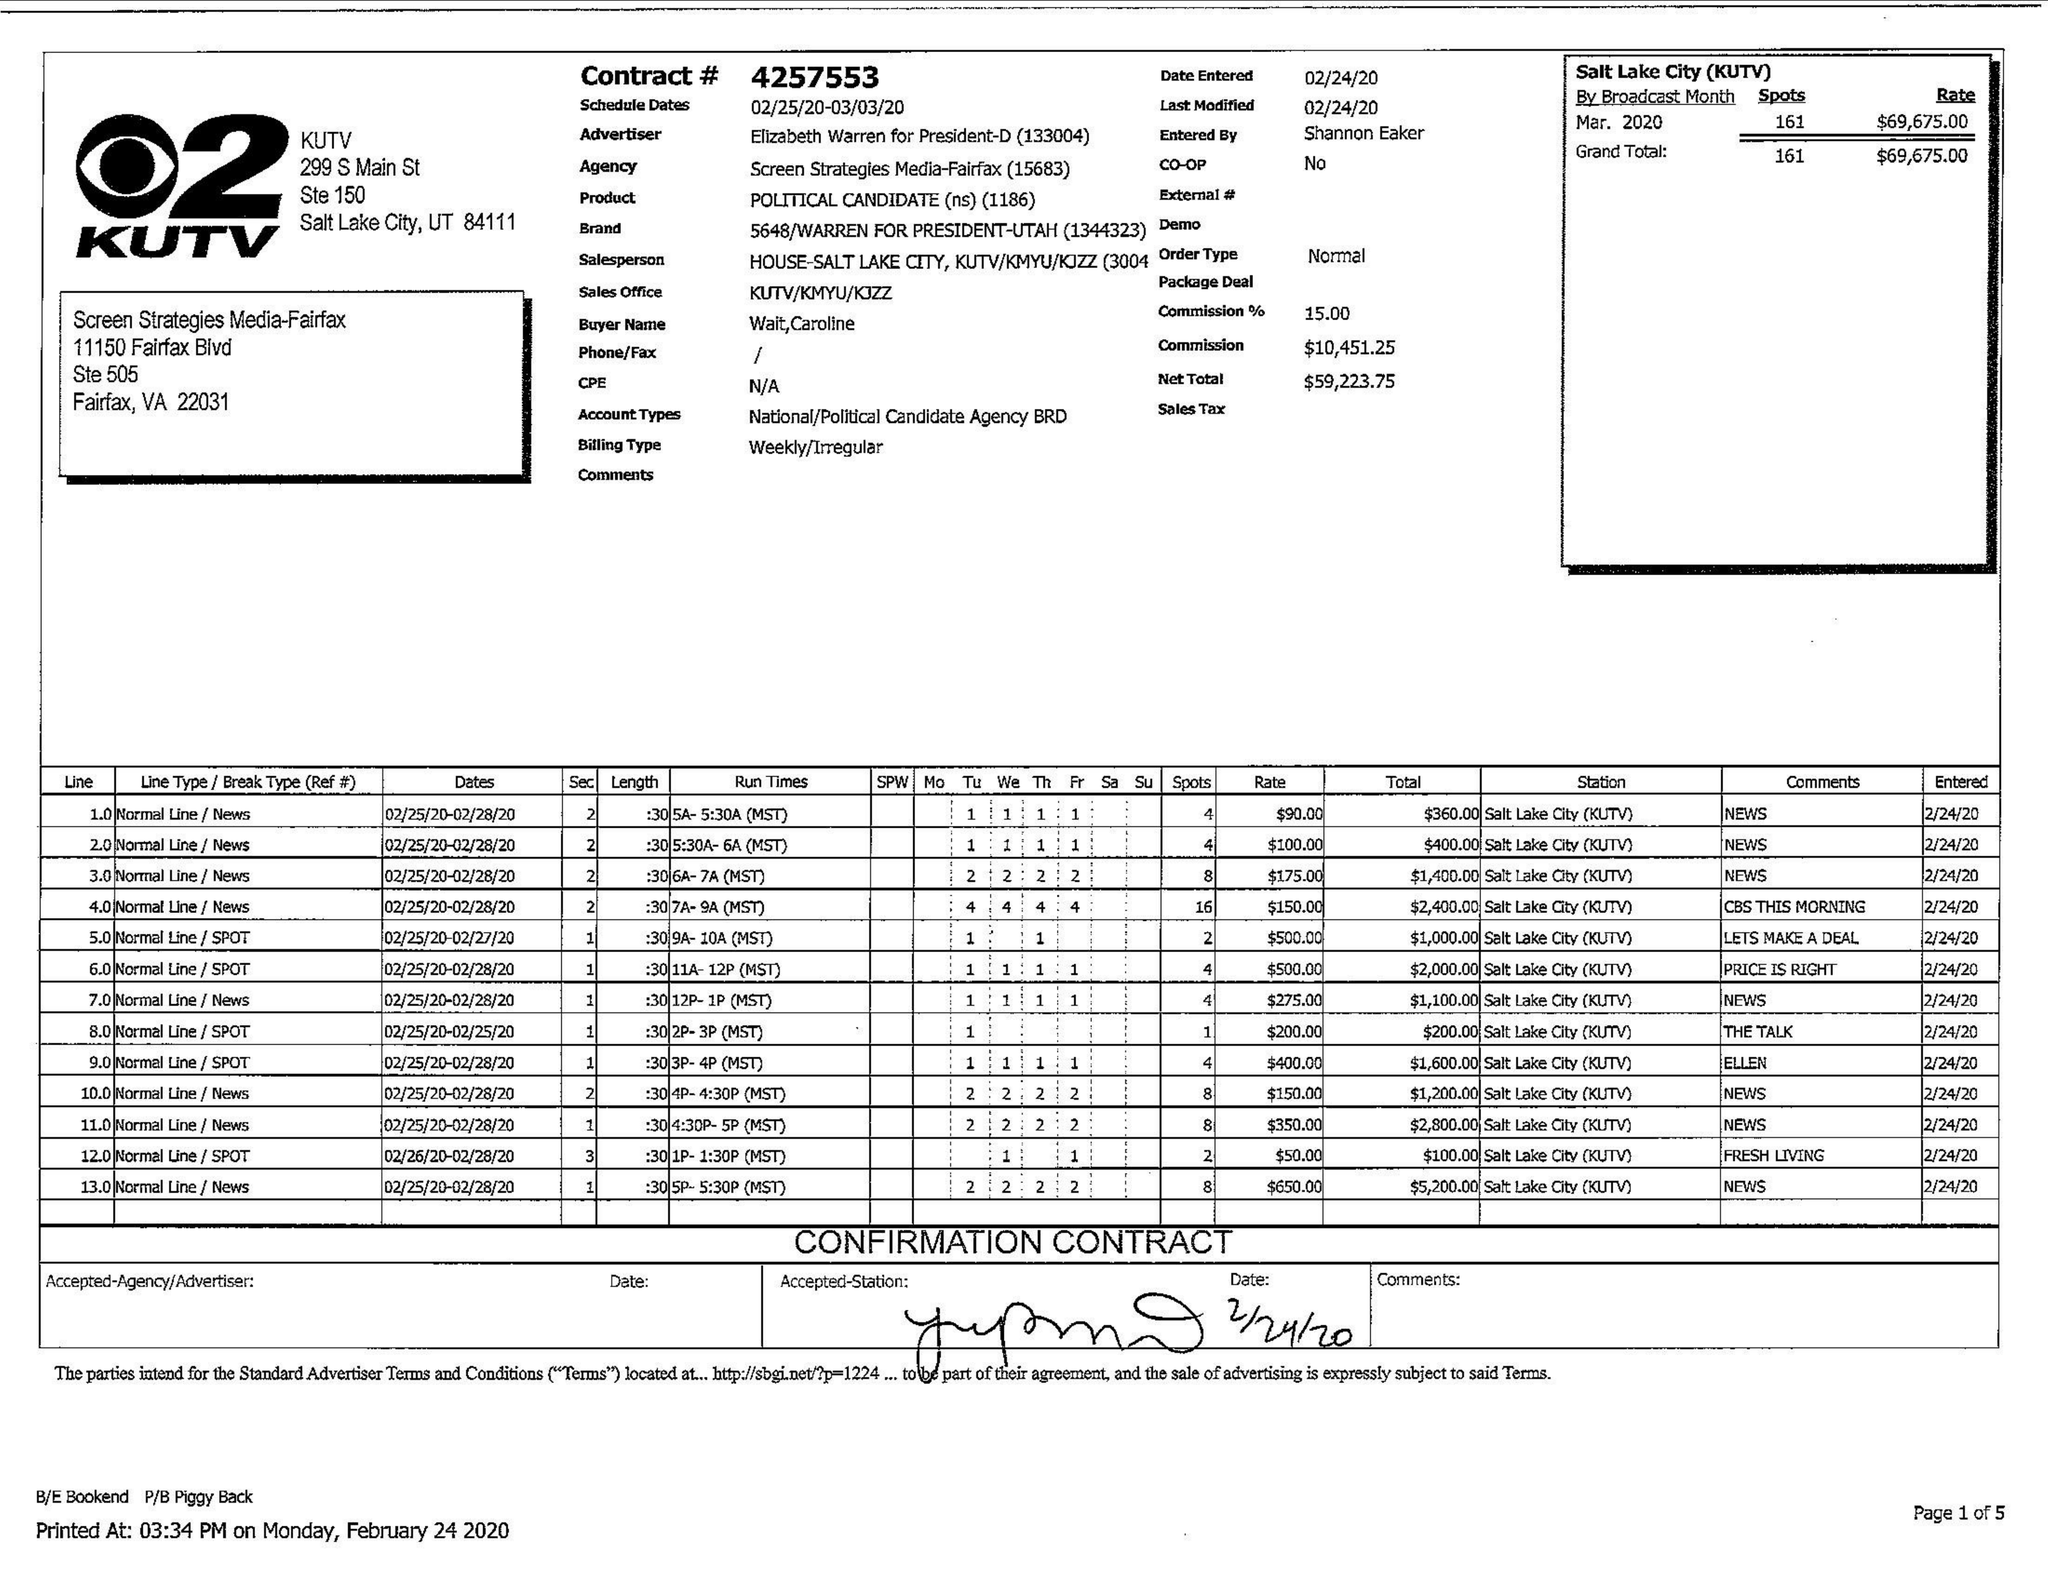What is the value for the advertiser?
Answer the question using a single word or phrase. ELIZABETH WARREN FOR PRESIDENT-D 